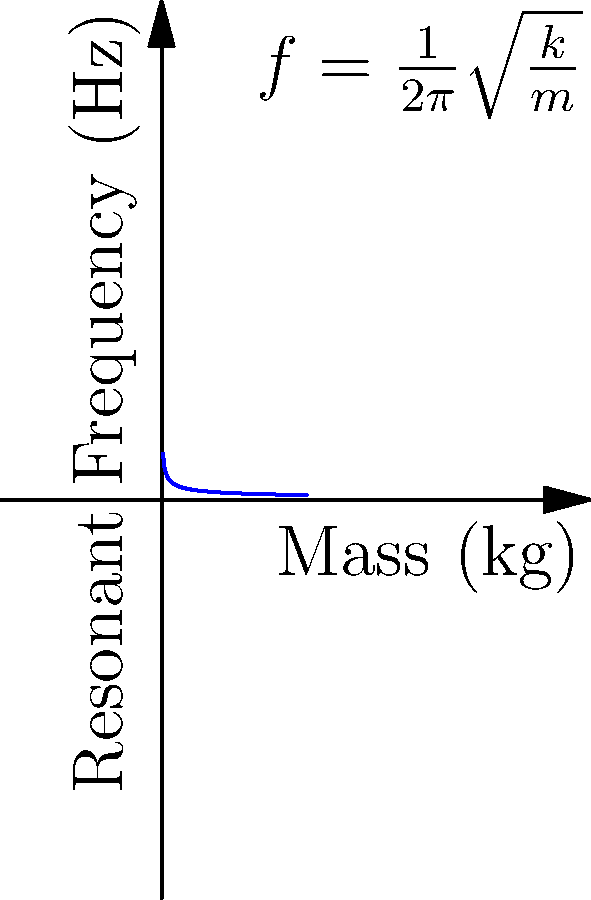You're customizing your tour bus with a sick subwoofer system. The suspension spring of your subwoofer has a spring constant of 1600 N/m. If you want the resonant frequency to be 40 Hz to match your signature bass drop, what should be the effective mass of the subwoofer cone in kg? To solve this problem, we'll use the formula for the resonant frequency of a simple harmonic oscillator:

$$ f = \frac{1}{2\pi}\sqrt{\frac{k}{m}} $$

Where:
$f$ is the resonant frequency in Hz
$k$ is the spring constant in N/m
$m$ is the effective mass in kg

We're given:
$f = 40$ Hz
$k = 1600$ N/m

Let's solve for $m$:

1) Start with the equation: $40 = \frac{1}{2\pi}\sqrt{\frac{1600}{m}}$

2) Square both sides: $1600 = \frac{1}{4\pi^2} \cdot \frac{1600}{m}$

3) Multiply both sides by $4\pi^2$: $6400\pi^2 = \frac{1600}{m}$

4) Multiply both sides by $m$: $6400\pi^2m = 1600$

5) Divide both sides by $6400\pi^2$: $m = \frac{1600}{6400\pi^2}$

6) Simplify: $m = \frac{1}{4\pi^2} \approx 0.0253$ kg

Therefore, the effective mass of the subwoofer cone should be approximately 0.0253 kg or 25.3 grams.
Answer: 0.0253 kg 